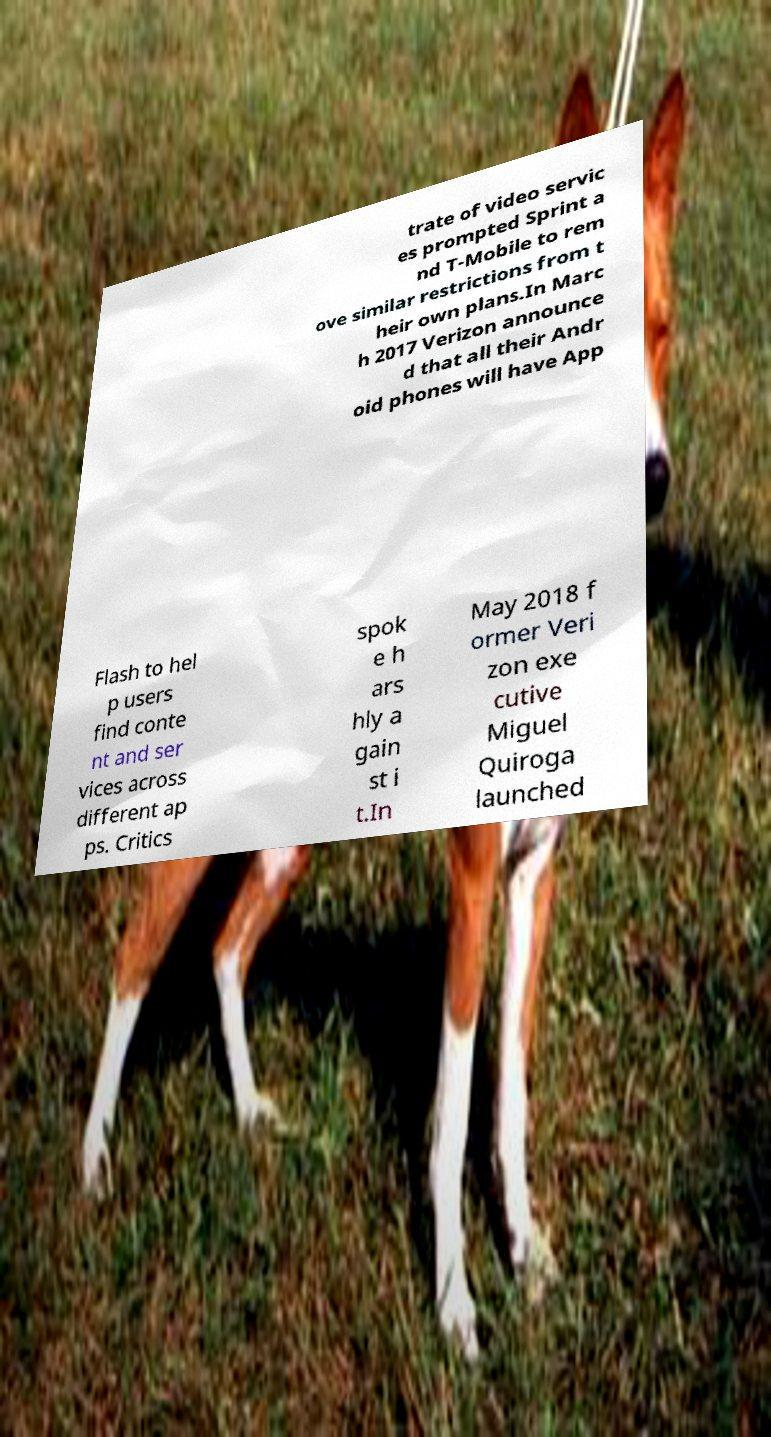Please identify and transcribe the text found in this image. trate of video servic es prompted Sprint a nd T-Mobile to rem ove similar restrictions from t heir own plans.In Marc h 2017 Verizon announce d that all their Andr oid phones will have App Flash to hel p users find conte nt and ser vices across different ap ps. Critics spok e h ars hly a gain st i t.In May 2018 f ormer Veri zon exe cutive Miguel Quiroga launched 